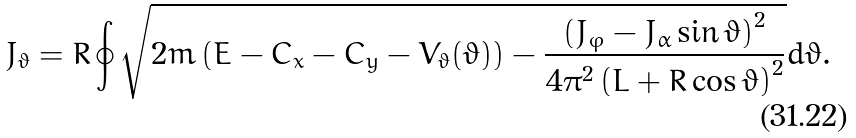Convert formula to latex. <formula><loc_0><loc_0><loc_500><loc_500>J _ { \vartheta } = R \oint \sqrt { 2 m \left ( E - C _ { x } - C _ { y } - V _ { \vartheta } ( \vartheta ) \right ) - \frac { \left ( J _ { \varphi } - J _ { \alpha } \sin \vartheta \right ) ^ { 2 } } { 4 \pi ^ { 2 } \left ( L + R \cos \vartheta \right ) ^ { 2 } } } d \vartheta .</formula> 